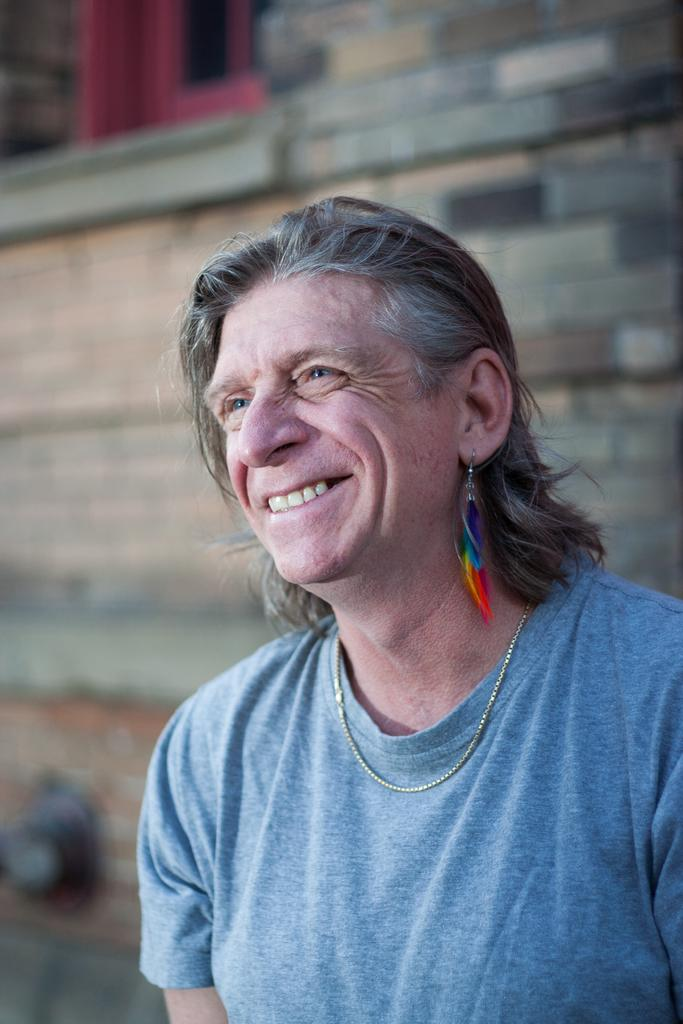Who is present in the image? There is a person in the image. What is the person's expression? The person is smiling. What can be seen in the background of the image? There is a wall and a window in the background of the image. What is the color of the window? The window is red in color. Can you hear the drum being played in the image? There is no drum present in the image, so it cannot be heard or played. 